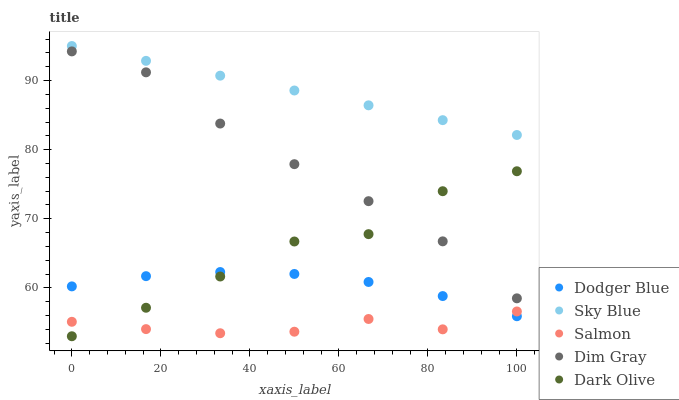Does Salmon have the minimum area under the curve?
Answer yes or no. Yes. Does Sky Blue have the maximum area under the curve?
Answer yes or no. Yes. Does Dim Gray have the minimum area under the curve?
Answer yes or no. No. Does Dim Gray have the maximum area under the curve?
Answer yes or no. No. Is Sky Blue the smoothest?
Answer yes or no. Yes. Is Dark Olive the roughest?
Answer yes or no. Yes. Is Dim Gray the smoothest?
Answer yes or no. No. Is Dim Gray the roughest?
Answer yes or no. No. Does Dark Olive have the lowest value?
Answer yes or no. Yes. Does Dim Gray have the lowest value?
Answer yes or no. No. Does Sky Blue have the highest value?
Answer yes or no. Yes. Does Dim Gray have the highest value?
Answer yes or no. No. Is Salmon less than Dim Gray?
Answer yes or no. Yes. Is Dim Gray greater than Dodger Blue?
Answer yes or no. Yes. Does Dark Olive intersect Dodger Blue?
Answer yes or no. Yes. Is Dark Olive less than Dodger Blue?
Answer yes or no. No. Is Dark Olive greater than Dodger Blue?
Answer yes or no. No. Does Salmon intersect Dim Gray?
Answer yes or no. No. 